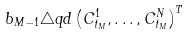<formula> <loc_0><loc_0><loc_500><loc_500>b _ { M - 1 } \triangle q d \left ( C ^ { 1 } _ { t _ { M } } , \dots , C ^ { N } _ { t _ { M } } \right ) ^ { T }</formula> 